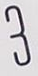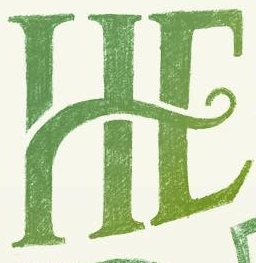Read the text content from these images in order, separated by a semicolon. 3; HE 